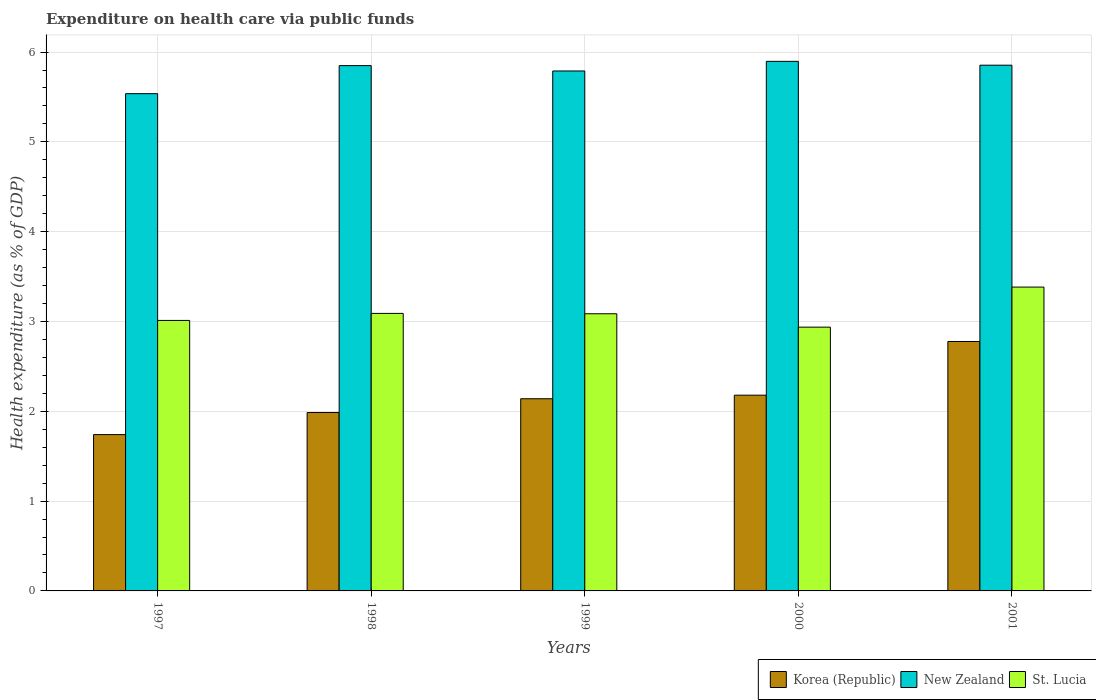Are the number of bars per tick equal to the number of legend labels?
Provide a short and direct response. Yes. How many bars are there on the 5th tick from the left?
Your answer should be very brief. 3. What is the label of the 1st group of bars from the left?
Provide a succinct answer. 1997. What is the expenditure made on health care in New Zealand in 2000?
Keep it short and to the point. 5.9. Across all years, what is the maximum expenditure made on health care in St. Lucia?
Provide a short and direct response. 3.38. Across all years, what is the minimum expenditure made on health care in St. Lucia?
Make the answer very short. 2.94. In which year was the expenditure made on health care in St. Lucia maximum?
Give a very brief answer. 2001. In which year was the expenditure made on health care in St. Lucia minimum?
Your answer should be very brief. 2000. What is the total expenditure made on health care in New Zealand in the graph?
Provide a short and direct response. 28.92. What is the difference between the expenditure made on health care in St. Lucia in 2000 and that in 2001?
Ensure brevity in your answer.  -0.45. What is the difference between the expenditure made on health care in Korea (Republic) in 1998 and the expenditure made on health care in New Zealand in 2001?
Your answer should be very brief. -3.87. What is the average expenditure made on health care in New Zealand per year?
Your answer should be very brief. 5.78. In the year 2001, what is the difference between the expenditure made on health care in St. Lucia and expenditure made on health care in New Zealand?
Provide a succinct answer. -2.47. What is the ratio of the expenditure made on health care in St. Lucia in 2000 to that in 2001?
Ensure brevity in your answer.  0.87. Is the expenditure made on health care in St. Lucia in 1999 less than that in 2001?
Ensure brevity in your answer.  Yes. Is the difference between the expenditure made on health care in St. Lucia in 1997 and 1998 greater than the difference between the expenditure made on health care in New Zealand in 1997 and 1998?
Provide a succinct answer. Yes. What is the difference between the highest and the second highest expenditure made on health care in St. Lucia?
Ensure brevity in your answer.  0.29. What is the difference between the highest and the lowest expenditure made on health care in St. Lucia?
Provide a succinct answer. 0.45. In how many years, is the expenditure made on health care in Korea (Republic) greater than the average expenditure made on health care in Korea (Republic) taken over all years?
Your answer should be very brief. 2. Is the sum of the expenditure made on health care in New Zealand in 1999 and 2000 greater than the maximum expenditure made on health care in Korea (Republic) across all years?
Make the answer very short. Yes. What does the 2nd bar from the left in 2001 represents?
Provide a short and direct response. New Zealand. How many years are there in the graph?
Give a very brief answer. 5. What is the difference between two consecutive major ticks on the Y-axis?
Ensure brevity in your answer.  1. How many legend labels are there?
Keep it short and to the point. 3. What is the title of the graph?
Your answer should be compact. Expenditure on health care via public funds. What is the label or title of the Y-axis?
Offer a terse response. Health expenditure (as % of GDP). What is the Health expenditure (as % of GDP) of Korea (Republic) in 1997?
Offer a terse response. 1.74. What is the Health expenditure (as % of GDP) in New Zealand in 1997?
Offer a terse response. 5.54. What is the Health expenditure (as % of GDP) of St. Lucia in 1997?
Give a very brief answer. 3.01. What is the Health expenditure (as % of GDP) of Korea (Republic) in 1998?
Give a very brief answer. 1.99. What is the Health expenditure (as % of GDP) of New Zealand in 1998?
Your response must be concise. 5.85. What is the Health expenditure (as % of GDP) of St. Lucia in 1998?
Ensure brevity in your answer.  3.09. What is the Health expenditure (as % of GDP) of Korea (Republic) in 1999?
Give a very brief answer. 2.14. What is the Health expenditure (as % of GDP) in New Zealand in 1999?
Offer a very short reply. 5.79. What is the Health expenditure (as % of GDP) of St. Lucia in 1999?
Make the answer very short. 3.09. What is the Health expenditure (as % of GDP) in Korea (Republic) in 2000?
Keep it short and to the point. 2.18. What is the Health expenditure (as % of GDP) of New Zealand in 2000?
Your answer should be very brief. 5.9. What is the Health expenditure (as % of GDP) of St. Lucia in 2000?
Your answer should be compact. 2.94. What is the Health expenditure (as % of GDP) of Korea (Republic) in 2001?
Your response must be concise. 2.78. What is the Health expenditure (as % of GDP) in New Zealand in 2001?
Make the answer very short. 5.85. What is the Health expenditure (as % of GDP) of St. Lucia in 2001?
Ensure brevity in your answer.  3.38. Across all years, what is the maximum Health expenditure (as % of GDP) of Korea (Republic)?
Your answer should be very brief. 2.78. Across all years, what is the maximum Health expenditure (as % of GDP) of New Zealand?
Provide a short and direct response. 5.9. Across all years, what is the maximum Health expenditure (as % of GDP) in St. Lucia?
Your answer should be very brief. 3.38. Across all years, what is the minimum Health expenditure (as % of GDP) of Korea (Republic)?
Ensure brevity in your answer.  1.74. Across all years, what is the minimum Health expenditure (as % of GDP) in New Zealand?
Your answer should be compact. 5.54. Across all years, what is the minimum Health expenditure (as % of GDP) of St. Lucia?
Make the answer very short. 2.94. What is the total Health expenditure (as % of GDP) of Korea (Republic) in the graph?
Offer a terse response. 10.82. What is the total Health expenditure (as % of GDP) of New Zealand in the graph?
Keep it short and to the point. 28.92. What is the total Health expenditure (as % of GDP) of St. Lucia in the graph?
Provide a short and direct response. 15.51. What is the difference between the Health expenditure (as % of GDP) in Korea (Republic) in 1997 and that in 1998?
Provide a short and direct response. -0.25. What is the difference between the Health expenditure (as % of GDP) of New Zealand in 1997 and that in 1998?
Offer a terse response. -0.31. What is the difference between the Health expenditure (as % of GDP) in St. Lucia in 1997 and that in 1998?
Keep it short and to the point. -0.08. What is the difference between the Health expenditure (as % of GDP) of Korea (Republic) in 1997 and that in 1999?
Ensure brevity in your answer.  -0.4. What is the difference between the Health expenditure (as % of GDP) in New Zealand in 1997 and that in 1999?
Provide a succinct answer. -0.25. What is the difference between the Health expenditure (as % of GDP) in St. Lucia in 1997 and that in 1999?
Provide a succinct answer. -0.07. What is the difference between the Health expenditure (as % of GDP) of Korea (Republic) in 1997 and that in 2000?
Your answer should be very brief. -0.44. What is the difference between the Health expenditure (as % of GDP) of New Zealand in 1997 and that in 2000?
Your answer should be very brief. -0.36. What is the difference between the Health expenditure (as % of GDP) in St. Lucia in 1997 and that in 2000?
Make the answer very short. 0.07. What is the difference between the Health expenditure (as % of GDP) of Korea (Republic) in 1997 and that in 2001?
Your answer should be compact. -1.04. What is the difference between the Health expenditure (as % of GDP) of New Zealand in 1997 and that in 2001?
Offer a very short reply. -0.32. What is the difference between the Health expenditure (as % of GDP) in St. Lucia in 1997 and that in 2001?
Make the answer very short. -0.37. What is the difference between the Health expenditure (as % of GDP) of Korea (Republic) in 1998 and that in 1999?
Ensure brevity in your answer.  -0.15. What is the difference between the Health expenditure (as % of GDP) in New Zealand in 1998 and that in 1999?
Give a very brief answer. 0.06. What is the difference between the Health expenditure (as % of GDP) in St. Lucia in 1998 and that in 1999?
Provide a succinct answer. 0. What is the difference between the Health expenditure (as % of GDP) of Korea (Republic) in 1998 and that in 2000?
Offer a very short reply. -0.19. What is the difference between the Health expenditure (as % of GDP) in New Zealand in 1998 and that in 2000?
Give a very brief answer. -0.05. What is the difference between the Health expenditure (as % of GDP) in St. Lucia in 1998 and that in 2000?
Provide a succinct answer. 0.15. What is the difference between the Health expenditure (as % of GDP) of Korea (Republic) in 1998 and that in 2001?
Your response must be concise. -0.79. What is the difference between the Health expenditure (as % of GDP) in New Zealand in 1998 and that in 2001?
Offer a terse response. -0. What is the difference between the Health expenditure (as % of GDP) in St. Lucia in 1998 and that in 2001?
Keep it short and to the point. -0.29. What is the difference between the Health expenditure (as % of GDP) in Korea (Republic) in 1999 and that in 2000?
Make the answer very short. -0.04. What is the difference between the Health expenditure (as % of GDP) in New Zealand in 1999 and that in 2000?
Offer a very short reply. -0.11. What is the difference between the Health expenditure (as % of GDP) of St. Lucia in 1999 and that in 2000?
Your answer should be compact. 0.15. What is the difference between the Health expenditure (as % of GDP) in Korea (Republic) in 1999 and that in 2001?
Your answer should be compact. -0.64. What is the difference between the Health expenditure (as % of GDP) of New Zealand in 1999 and that in 2001?
Ensure brevity in your answer.  -0.06. What is the difference between the Health expenditure (as % of GDP) in St. Lucia in 1999 and that in 2001?
Offer a very short reply. -0.3. What is the difference between the Health expenditure (as % of GDP) of Korea (Republic) in 2000 and that in 2001?
Offer a terse response. -0.6. What is the difference between the Health expenditure (as % of GDP) of New Zealand in 2000 and that in 2001?
Keep it short and to the point. 0.04. What is the difference between the Health expenditure (as % of GDP) in St. Lucia in 2000 and that in 2001?
Make the answer very short. -0.45. What is the difference between the Health expenditure (as % of GDP) in Korea (Republic) in 1997 and the Health expenditure (as % of GDP) in New Zealand in 1998?
Give a very brief answer. -4.11. What is the difference between the Health expenditure (as % of GDP) in Korea (Republic) in 1997 and the Health expenditure (as % of GDP) in St. Lucia in 1998?
Offer a very short reply. -1.35. What is the difference between the Health expenditure (as % of GDP) of New Zealand in 1997 and the Health expenditure (as % of GDP) of St. Lucia in 1998?
Your answer should be very brief. 2.45. What is the difference between the Health expenditure (as % of GDP) of Korea (Republic) in 1997 and the Health expenditure (as % of GDP) of New Zealand in 1999?
Your answer should be compact. -4.05. What is the difference between the Health expenditure (as % of GDP) in Korea (Republic) in 1997 and the Health expenditure (as % of GDP) in St. Lucia in 1999?
Your answer should be compact. -1.35. What is the difference between the Health expenditure (as % of GDP) in New Zealand in 1997 and the Health expenditure (as % of GDP) in St. Lucia in 1999?
Make the answer very short. 2.45. What is the difference between the Health expenditure (as % of GDP) in Korea (Republic) in 1997 and the Health expenditure (as % of GDP) in New Zealand in 2000?
Keep it short and to the point. -4.16. What is the difference between the Health expenditure (as % of GDP) of Korea (Republic) in 1997 and the Health expenditure (as % of GDP) of St. Lucia in 2000?
Provide a short and direct response. -1.2. What is the difference between the Health expenditure (as % of GDP) of New Zealand in 1997 and the Health expenditure (as % of GDP) of St. Lucia in 2000?
Your response must be concise. 2.6. What is the difference between the Health expenditure (as % of GDP) of Korea (Republic) in 1997 and the Health expenditure (as % of GDP) of New Zealand in 2001?
Offer a very short reply. -4.11. What is the difference between the Health expenditure (as % of GDP) of Korea (Republic) in 1997 and the Health expenditure (as % of GDP) of St. Lucia in 2001?
Make the answer very short. -1.64. What is the difference between the Health expenditure (as % of GDP) of New Zealand in 1997 and the Health expenditure (as % of GDP) of St. Lucia in 2001?
Your answer should be compact. 2.15. What is the difference between the Health expenditure (as % of GDP) of Korea (Republic) in 1998 and the Health expenditure (as % of GDP) of New Zealand in 1999?
Your answer should be compact. -3.8. What is the difference between the Health expenditure (as % of GDP) of Korea (Republic) in 1998 and the Health expenditure (as % of GDP) of St. Lucia in 1999?
Provide a succinct answer. -1.1. What is the difference between the Health expenditure (as % of GDP) of New Zealand in 1998 and the Health expenditure (as % of GDP) of St. Lucia in 1999?
Your answer should be compact. 2.76. What is the difference between the Health expenditure (as % of GDP) of Korea (Republic) in 1998 and the Health expenditure (as % of GDP) of New Zealand in 2000?
Provide a succinct answer. -3.91. What is the difference between the Health expenditure (as % of GDP) of Korea (Republic) in 1998 and the Health expenditure (as % of GDP) of St. Lucia in 2000?
Make the answer very short. -0.95. What is the difference between the Health expenditure (as % of GDP) in New Zealand in 1998 and the Health expenditure (as % of GDP) in St. Lucia in 2000?
Your answer should be compact. 2.91. What is the difference between the Health expenditure (as % of GDP) of Korea (Republic) in 1998 and the Health expenditure (as % of GDP) of New Zealand in 2001?
Make the answer very short. -3.87. What is the difference between the Health expenditure (as % of GDP) in Korea (Republic) in 1998 and the Health expenditure (as % of GDP) in St. Lucia in 2001?
Keep it short and to the point. -1.4. What is the difference between the Health expenditure (as % of GDP) in New Zealand in 1998 and the Health expenditure (as % of GDP) in St. Lucia in 2001?
Your answer should be compact. 2.47. What is the difference between the Health expenditure (as % of GDP) in Korea (Republic) in 1999 and the Health expenditure (as % of GDP) in New Zealand in 2000?
Provide a succinct answer. -3.76. What is the difference between the Health expenditure (as % of GDP) of Korea (Republic) in 1999 and the Health expenditure (as % of GDP) of St. Lucia in 2000?
Your answer should be compact. -0.8. What is the difference between the Health expenditure (as % of GDP) in New Zealand in 1999 and the Health expenditure (as % of GDP) in St. Lucia in 2000?
Provide a succinct answer. 2.85. What is the difference between the Health expenditure (as % of GDP) in Korea (Republic) in 1999 and the Health expenditure (as % of GDP) in New Zealand in 2001?
Your response must be concise. -3.71. What is the difference between the Health expenditure (as % of GDP) in Korea (Republic) in 1999 and the Health expenditure (as % of GDP) in St. Lucia in 2001?
Your answer should be compact. -1.24. What is the difference between the Health expenditure (as % of GDP) of New Zealand in 1999 and the Health expenditure (as % of GDP) of St. Lucia in 2001?
Provide a short and direct response. 2.41. What is the difference between the Health expenditure (as % of GDP) in Korea (Republic) in 2000 and the Health expenditure (as % of GDP) in New Zealand in 2001?
Make the answer very short. -3.67. What is the difference between the Health expenditure (as % of GDP) of Korea (Republic) in 2000 and the Health expenditure (as % of GDP) of St. Lucia in 2001?
Provide a succinct answer. -1.2. What is the difference between the Health expenditure (as % of GDP) of New Zealand in 2000 and the Health expenditure (as % of GDP) of St. Lucia in 2001?
Your answer should be very brief. 2.51. What is the average Health expenditure (as % of GDP) of Korea (Republic) per year?
Your answer should be compact. 2.16. What is the average Health expenditure (as % of GDP) of New Zealand per year?
Keep it short and to the point. 5.78. What is the average Health expenditure (as % of GDP) in St. Lucia per year?
Offer a terse response. 3.1. In the year 1997, what is the difference between the Health expenditure (as % of GDP) in Korea (Republic) and Health expenditure (as % of GDP) in New Zealand?
Provide a short and direct response. -3.8. In the year 1997, what is the difference between the Health expenditure (as % of GDP) of Korea (Republic) and Health expenditure (as % of GDP) of St. Lucia?
Your answer should be very brief. -1.27. In the year 1997, what is the difference between the Health expenditure (as % of GDP) of New Zealand and Health expenditure (as % of GDP) of St. Lucia?
Provide a short and direct response. 2.52. In the year 1998, what is the difference between the Health expenditure (as % of GDP) in Korea (Republic) and Health expenditure (as % of GDP) in New Zealand?
Your answer should be compact. -3.86. In the year 1998, what is the difference between the Health expenditure (as % of GDP) in Korea (Republic) and Health expenditure (as % of GDP) in St. Lucia?
Your answer should be very brief. -1.1. In the year 1998, what is the difference between the Health expenditure (as % of GDP) in New Zealand and Health expenditure (as % of GDP) in St. Lucia?
Offer a very short reply. 2.76. In the year 1999, what is the difference between the Health expenditure (as % of GDP) of Korea (Republic) and Health expenditure (as % of GDP) of New Zealand?
Your answer should be compact. -3.65. In the year 1999, what is the difference between the Health expenditure (as % of GDP) in Korea (Republic) and Health expenditure (as % of GDP) in St. Lucia?
Your response must be concise. -0.95. In the year 1999, what is the difference between the Health expenditure (as % of GDP) of New Zealand and Health expenditure (as % of GDP) of St. Lucia?
Your answer should be compact. 2.7. In the year 2000, what is the difference between the Health expenditure (as % of GDP) of Korea (Republic) and Health expenditure (as % of GDP) of New Zealand?
Your answer should be compact. -3.72. In the year 2000, what is the difference between the Health expenditure (as % of GDP) in Korea (Republic) and Health expenditure (as % of GDP) in St. Lucia?
Your answer should be compact. -0.76. In the year 2000, what is the difference between the Health expenditure (as % of GDP) of New Zealand and Health expenditure (as % of GDP) of St. Lucia?
Keep it short and to the point. 2.96. In the year 2001, what is the difference between the Health expenditure (as % of GDP) in Korea (Republic) and Health expenditure (as % of GDP) in New Zealand?
Offer a very short reply. -3.08. In the year 2001, what is the difference between the Health expenditure (as % of GDP) of Korea (Republic) and Health expenditure (as % of GDP) of St. Lucia?
Keep it short and to the point. -0.61. In the year 2001, what is the difference between the Health expenditure (as % of GDP) of New Zealand and Health expenditure (as % of GDP) of St. Lucia?
Provide a short and direct response. 2.47. What is the ratio of the Health expenditure (as % of GDP) of Korea (Republic) in 1997 to that in 1998?
Your answer should be very brief. 0.88. What is the ratio of the Health expenditure (as % of GDP) in New Zealand in 1997 to that in 1998?
Your answer should be very brief. 0.95. What is the ratio of the Health expenditure (as % of GDP) of St. Lucia in 1997 to that in 1998?
Your answer should be very brief. 0.97. What is the ratio of the Health expenditure (as % of GDP) of Korea (Republic) in 1997 to that in 1999?
Your answer should be compact. 0.81. What is the ratio of the Health expenditure (as % of GDP) of New Zealand in 1997 to that in 1999?
Give a very brief answer. 0.96. What is the ratio of the Health expenditure (as % of GDP) of St. Lucia in 1997 to that in 1999?
Offer a very short reply. 0.98. What is the ratio of the Health expenditure (as % of GDP) of Korea (Republic) in 1997 to that in 2000?
Offer a terse response. 0.8. What is the ratio of the Health expenditure (as % of GDP) of New Zealand in 1997 to that in 2000?
Provide a succinct answer. 0.94. What is the ratio of the Health expenditure (as % of GDP) of St. Lucia in 1997 to that in 2000?
Your answer should be compact. 1.03. What is the ratio of the Health expenditure (as % of GDP) of Korea (Republic) in 1997 to that in 2001?
Your answer should be compact. 0.63. What is the ratio of the Health expenditure (as % of GDP) of New Zealand in 1997 to that in 2001?
Offer a terse response. 0.95. What is the ratio of the Health expenditure (as % of GDP) of St. Lucia in 1997 to that in 2001?
Ensure brevity in your answer.  0.89. What is the ratio of the Health expenditure (as % of GDP) in Korea (Republic) in 1998 to that in 1999?
Ensure brevity in your answer.  0.93. What is the ratio of the Health expenditure (as % of GDP) of New Zealand in 1998 to that in 1999?
Make the answer very short. 1.01. What is the ratio of the Health expenditure (as % of GDP) of St. Lucia in 1998 to that in 1999?
Ensure brevity in your answer.  1. What is the ratio of the Health expenditure (as % of GDP) of Korea (Republic) in 1998 to that in 2000?
Your response must be concise. 0.91. What is the ratio of the Health expenditure (as % of GDP) of St. Lucia in 1998 to that in 2000?
Provide a short and direct response. 1.05. What is the ratio of the Health expenditure (as % of GDP) in Korea (Republic) in 1998 to that in 2001?
Offer a very short reply. 0.72. What is the ratio of the Health expenditure (as % of GDP) in St. Lucia in 1998 to that in 2001?
Keep it short and to the point. 0.91. What is the ratio of the Health expenditure (as % of GDP) in Korea (Republic) in 1999 to that in 2000?
Give a very brief answer. 0.98. What is the ratio of the Health expenditure (as % of GDP) of New Zealand in 1999 to that in 2000?
Provide a short and direct response. 0.98. What is the ratio of the Health expenditure (as % of GDP) of St. Lucia in 1999 to that in 2000?
Give a very brief answer. 1.05. What is the ratio of the Health expenditure (as % of GDP) of Korea (Republic) in 1999 to that in 2001?
Offer a terse response. 0.77. What is the ratio of the Health expenditure (as % of GDP) of New Zealand in 1999 to that in 2001?
Provide a short and direct response. 0.99. What is the ratio of the Health expenditure (as % of GDP) of St. Lucia in 1999 to that in 2001?
Give a very brief answer. 0.91. What is the ratio of the Health expenditure (as % of GDP) in Korea (Republic) in 2000 to that in 2001?
Your answer should be very brief. 0.78. What is the ratio of the Health expenditure (as % of GDP) in New Zealand in 2000 to that in 2001?
Keep it short and to the point. 1.01. What is the ratio of the Health expenditure (as % of GDP) of St. Lucia in 2000 to that in 2001?
Offer a very short reply. 0.87. What is the difference between the highest and the second highest Health expenditure (as % of GDP) of Korea (Republic)?
Your answer should be very brief. 0.6. What is the difference between the highest and the second highest Health expenditure (as % of GDP) in New Zealand?
Your answer should be compact. 0.04. What is the difference between the highest and the second highest Health expenditure (as % of GDP) in St. Lucia?
Offer a terse response. 0.29. What is the difference between the highest and the lowest Health expenditure (as % of GDP) of Korea (Republic)?
Offer a terse response. 1.04. What is the difference between the highest and the lowest Health expenditure (as % of GDP) of New Zealand?
Offer a terse response. 0.36. What is the difference between the highest and the lowest Health expenditure (as % of GDP) in St. Lucia?
Your answer should be compact. 0.45. 